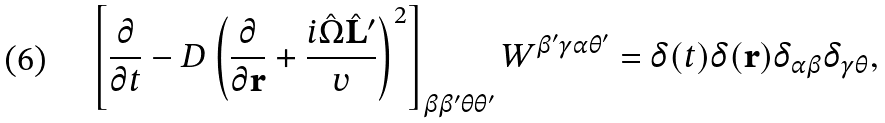Convert formula to latex. <formula><loc_0><loc_0><loc_500><loc_500>\left [ \frac { \partial } { \partial t } - D \left ( \frac { \partial } { \partial \mathbf r } + \frac { i \hat { \Omega } \hat { \mathbf L } ^ { \prime } } { v } \right ) ^ { 2 } \right ] _ { \beta \beta ^ { \prime } \theta \theta ^ { \prime } } W ^ { \beta ^ { \prime } \gamma \alpha \theta ^ { \prime } } = \delta ( t ) \delta ( \mathbf r ) \delta _ { \alpha \beta } \delta _ { \gamma \theta } ,</formula> 